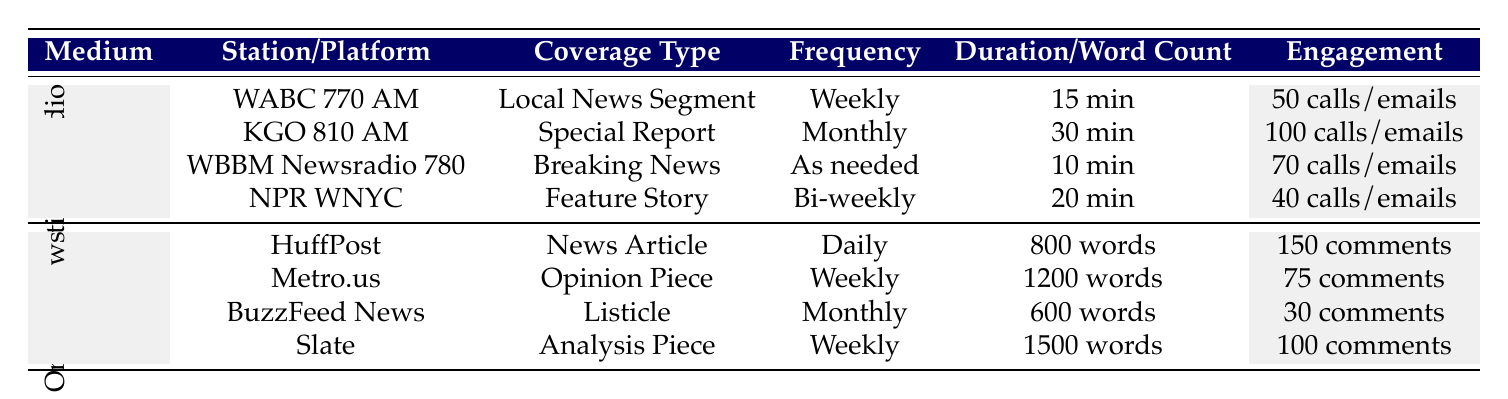What is the frequency of local news segments on WABC 770 AM? The table indicates that WABC 770 AM has a frequency listed as "Weekly" for the local news segment.
Answer: Weekly Which online news source has the highest average audience engagement? The table compares average audience engagement levels: HuffPost has 150 comments, Slate has 100 comments, Metro.us has 75 comments, and BuzzFeed News has 30 comments. Therefore, HuffPost has the highest.
Answer: HuffPost How many total minutes of coverage does KGO 810 AM provide per month? KGO 810 AM has a special report with a duration of 30 minutes and a frequency of monthly coverage. Thus, the total is 30 minutes per month.
Answer: 30 minutes What is the total audience engagement for all traditional radio stations? The audience engagement from traditional radio stations is calculated as follows: 50 + 100 + 70 + 40 = 260 calls/emails.
Answer: 260 calls/emails Does NPR WNYC cover local events? NPR WNYC covers topics like "Local Culture," which implies it covers local events. Therefore, the answer is yes.
Answer: Yes Compare the average word count of online sources to the duration of traditional radio coverage. Which is generally longer? The average word count can be calculated as (800 + 1200 + 600 + 1500) / 4 = 775 words. The average duration for traditional radio coverage is (15 + 30 + 10 + 20) / 4 = 18.75 minutes. Since time durations cannot be simply compared to word counts, it's not straightforward, but generally, written articles are longer in total words except a few long specials. The word count tends to be higher than the durations of radio pieces.
Answer: Generally longer What type of coverage does BuzzFeed News provide, and how often? BuzzFeed News provides a listicle as the coverage type, and it has a frequency of "Monthly."
Answer: Listicle, Monthly Which platform has the most varied topics covered in its segments? HuffPost covers "Local Protests," "Youth Engagement," and "Environmental Issues," making it among the more varied sources. Comparing all, Metro.us has a variety of "Gentrification", "Local Policy Changes", and "Cultural Shifts." However, the question of variety is subjective without a clear metric. On a topic count (3 for HuffPost, 3 for Metro.us, 2 for the others), they tie. Therefore, they may be considered equally varied.
Answer: HuffPost and Metro.us How does the frequency of coverage compare between traditional radio and online sources? Traditional radio maintains frequencies of weekly, monthly, bi-weekly, and as needed. Online news sources tend to engage in daily and weekly coverage mostly. Comparing directly, online sources have more daily updates, while traditional tends to provide in-depth pieces on monthly intervals (including breaking news as required).
Answer: Online sources have more frequent coverage overall 